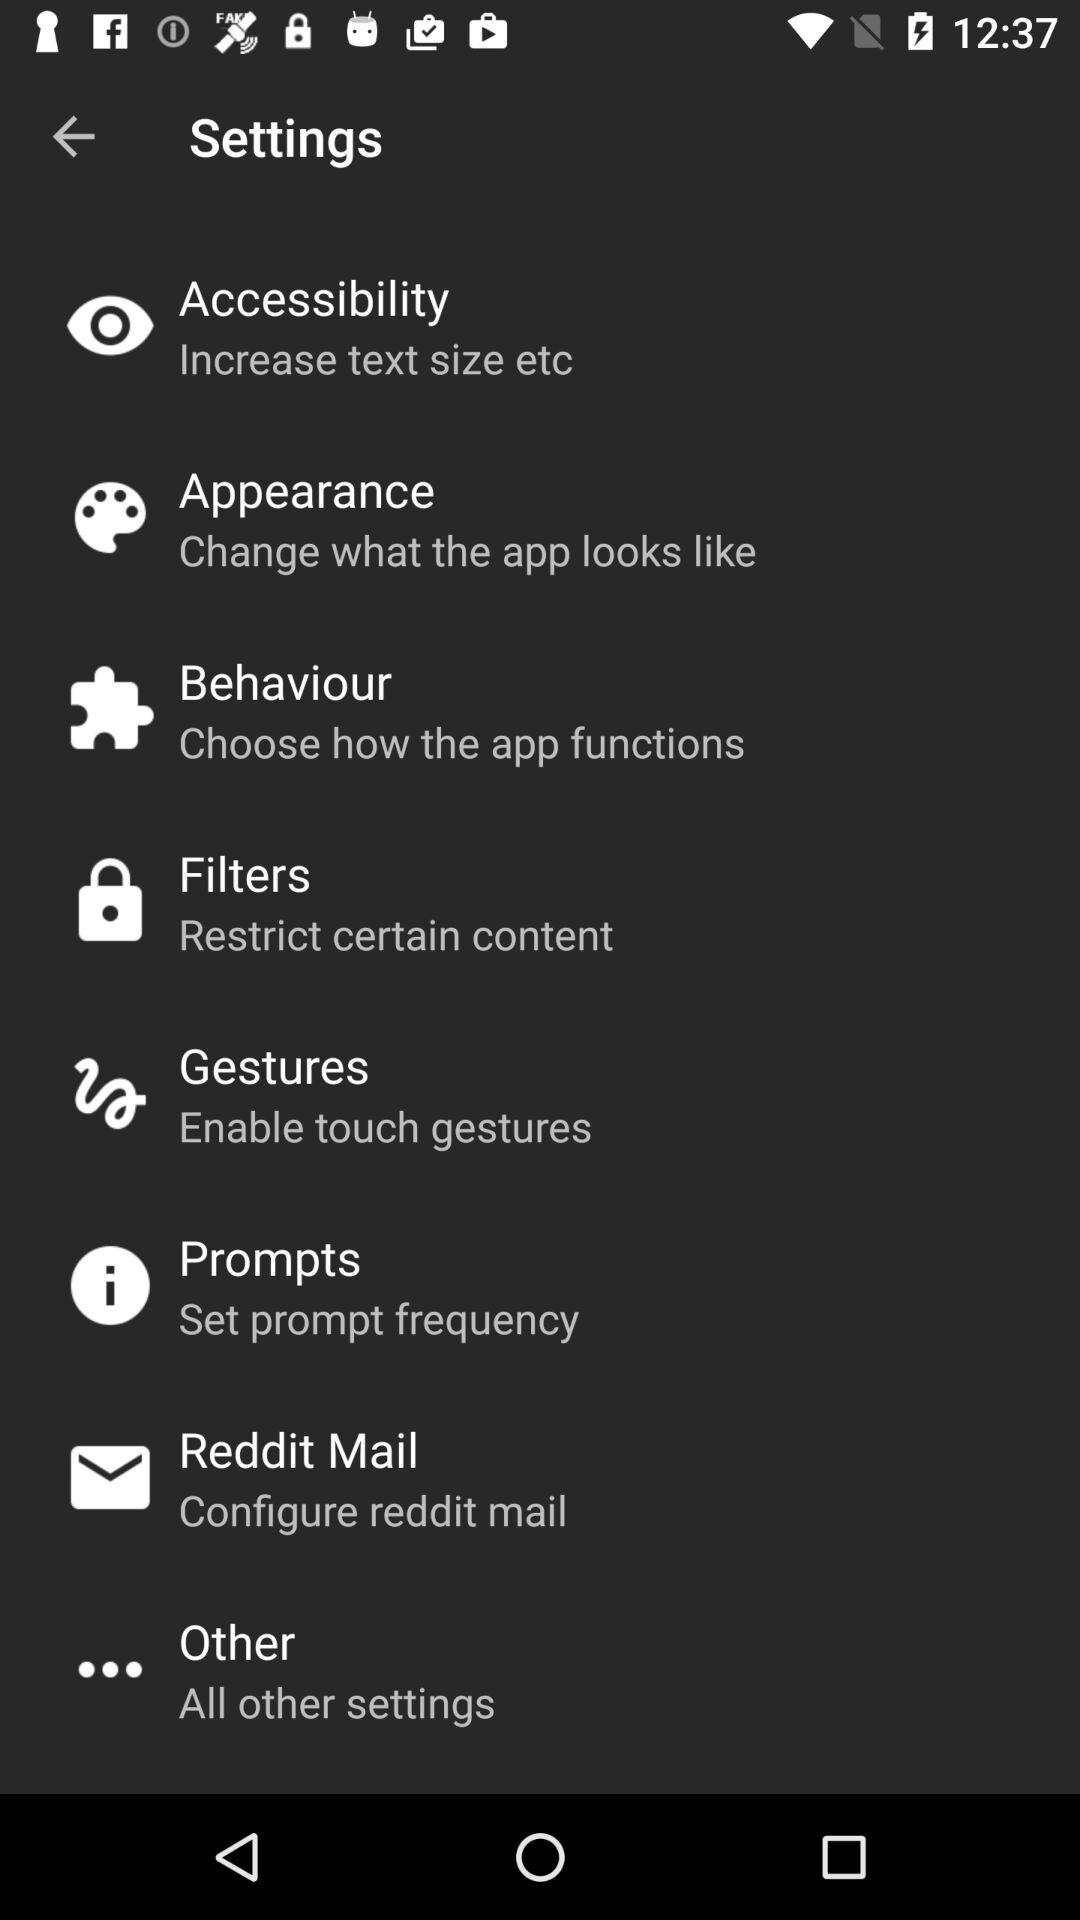How many items are there in the settings menu?
Answer the question using a single word or phrase. 8 